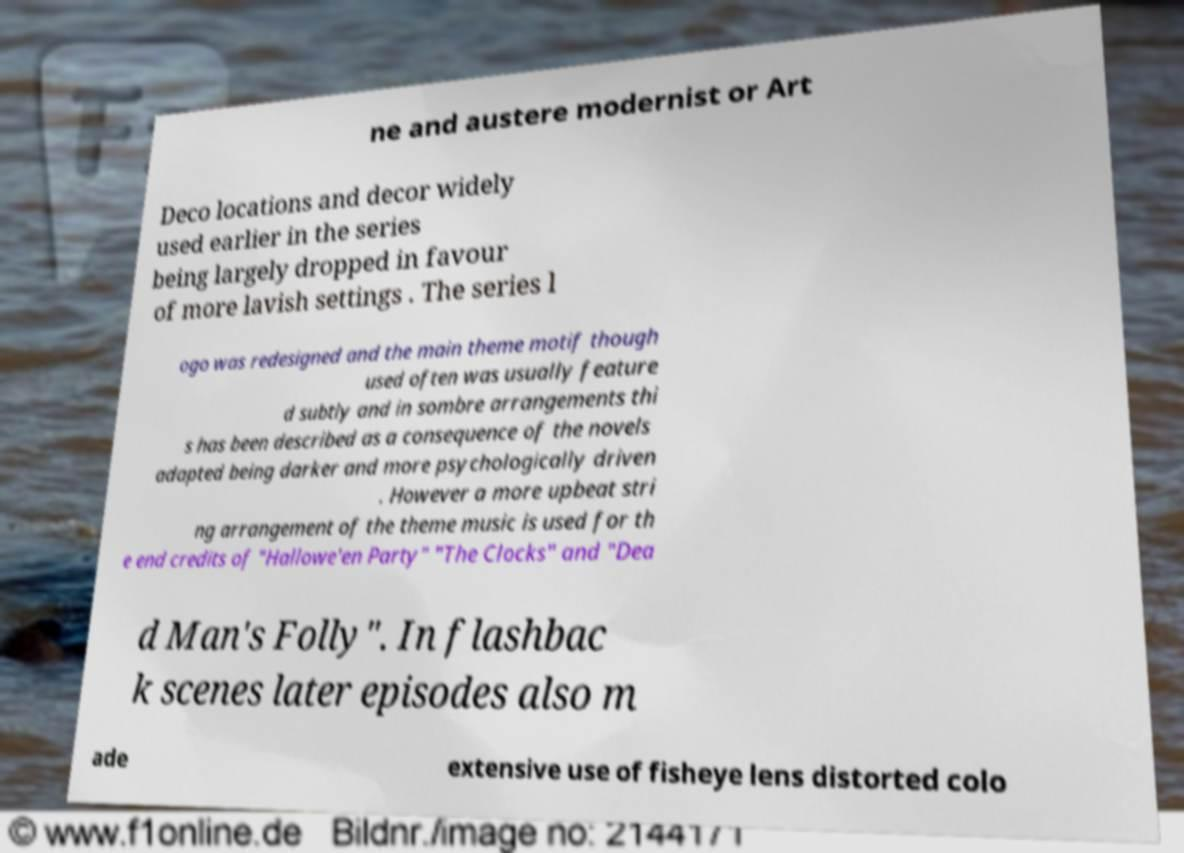Please identify and transcribe the text found in this image. ne and austere modernist or Art Deco locations and decor widely used earlier in the series being largely dropped in favour of more lavish settings . The series l ogo was redesigned and the main theme motif though used often was usually feature d subtly and in sombre arrangements thi s has been described as a consequence of the novels adapted being darker and more psychologically driven . However a more upbeat stri ng arrangement of the theme music is used for th e end credits of "Hallowe'en Party" "The Clocks" and "Dea d Man's Folly". In flashbac k scenes later episodes also m ade extensive use of fisheye lens distorted colo 